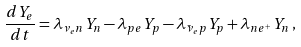Convert formula to latex. <formula><loc_0><loc_0><loc_500><loc_500>\frac { d Y _ { e } } { d t } = \lambda _ { \nu _ { e } n } Y _ { n } - \lambda _ { p e } Y _ { p } - \lambda _ { \bar { \nu } _ { e } p } Y _ { p } + \lambda _ { n e ^ { + } } Y _ { n } \, ,</formula> 